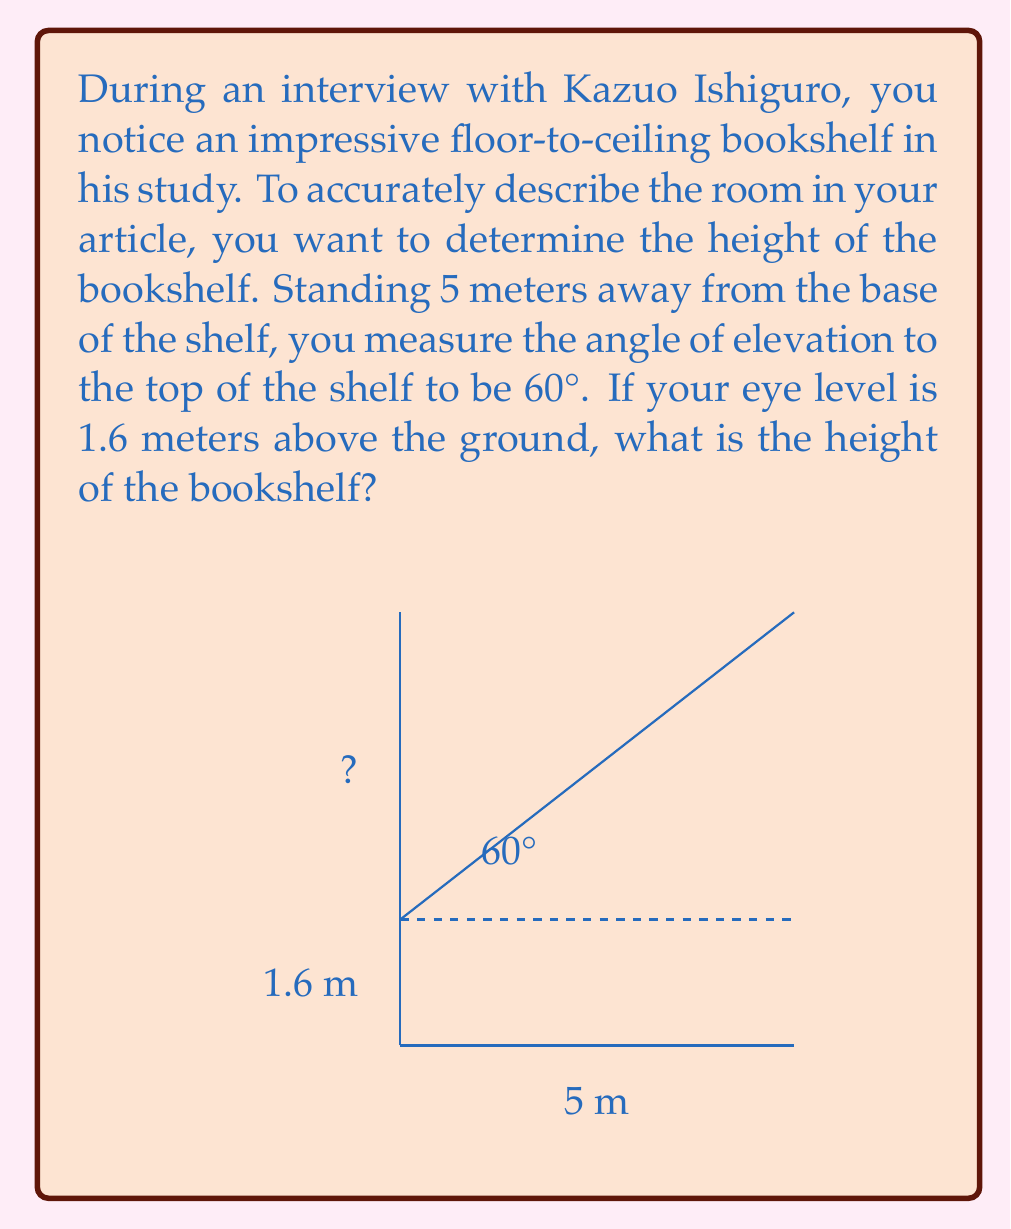Can you solve this math problem? Let's approach this step-by-step using trigonometric ratios:

1) First, we need to identify the known variables:
   - Distance from the bookshelf: 5 meters
   - Angle of elevation: 60°
   - Your eye level: 1.6 meters

2) We can use the tangent ratio to find the height from your eye level to the top of the bookshelf. The tangent of an angle in a right triangle is the ratio of the opposite side to the adjacent side.

   $$\tan 60° = \frac{\text{height above eye level}}{\text{distance}}$$

3) We know that $\tan 60° = \sqrt{3}$, so we can set up the equation:

   $$\sqrt{3} = \frac{\text{height above eye level}}{5}$$

4) Solve for the height above eye level:

   $$\text{height above eye level} = 5\sqrt{3} \approx 8.66 \text{ meters}$$

5) To get the total height of the bookshelf, we need to add your eye level to this height:

   $$\text{total height} = 8.66 + 1.6 = 10.26 \text{ meters}$$

Therefore, the bookshelf is approximately 10.26 meters tall.
Answer: The height of the bookshelf is approximately 10.26 meters. 